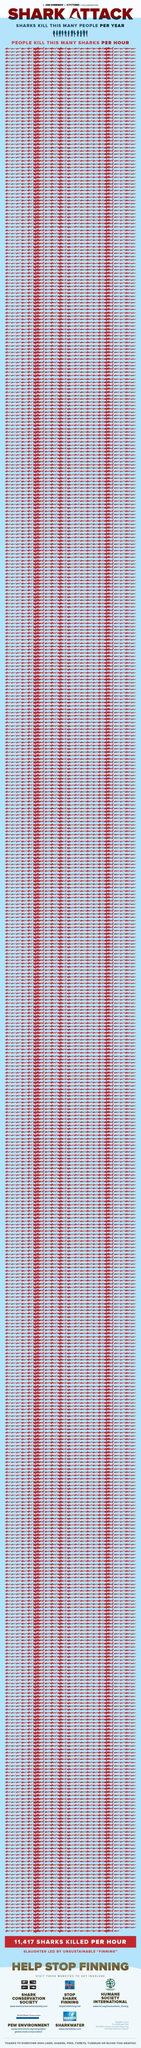Draw attention to some important aspects in this diagram. According to recent statistics, an average of 12 people are killed by sharks each year worldwide. 